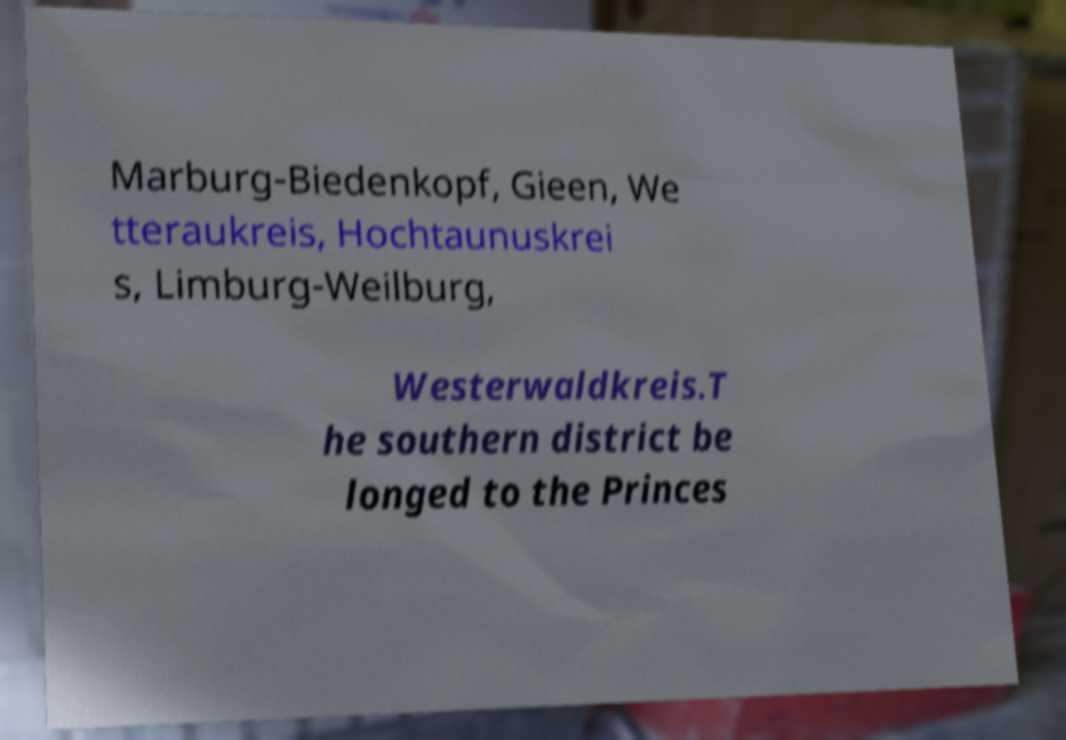Can you read and provide the text displayed in the image?This photo seems to have some interesting text. Can you extract and type it out for me? Marburg-Biedenkopf, Gieen, We tteraukreis, Hochtaunuskrei s, Limburg-Weilburg, Westerwaldkreis.T he southern district be longed to the Princes 